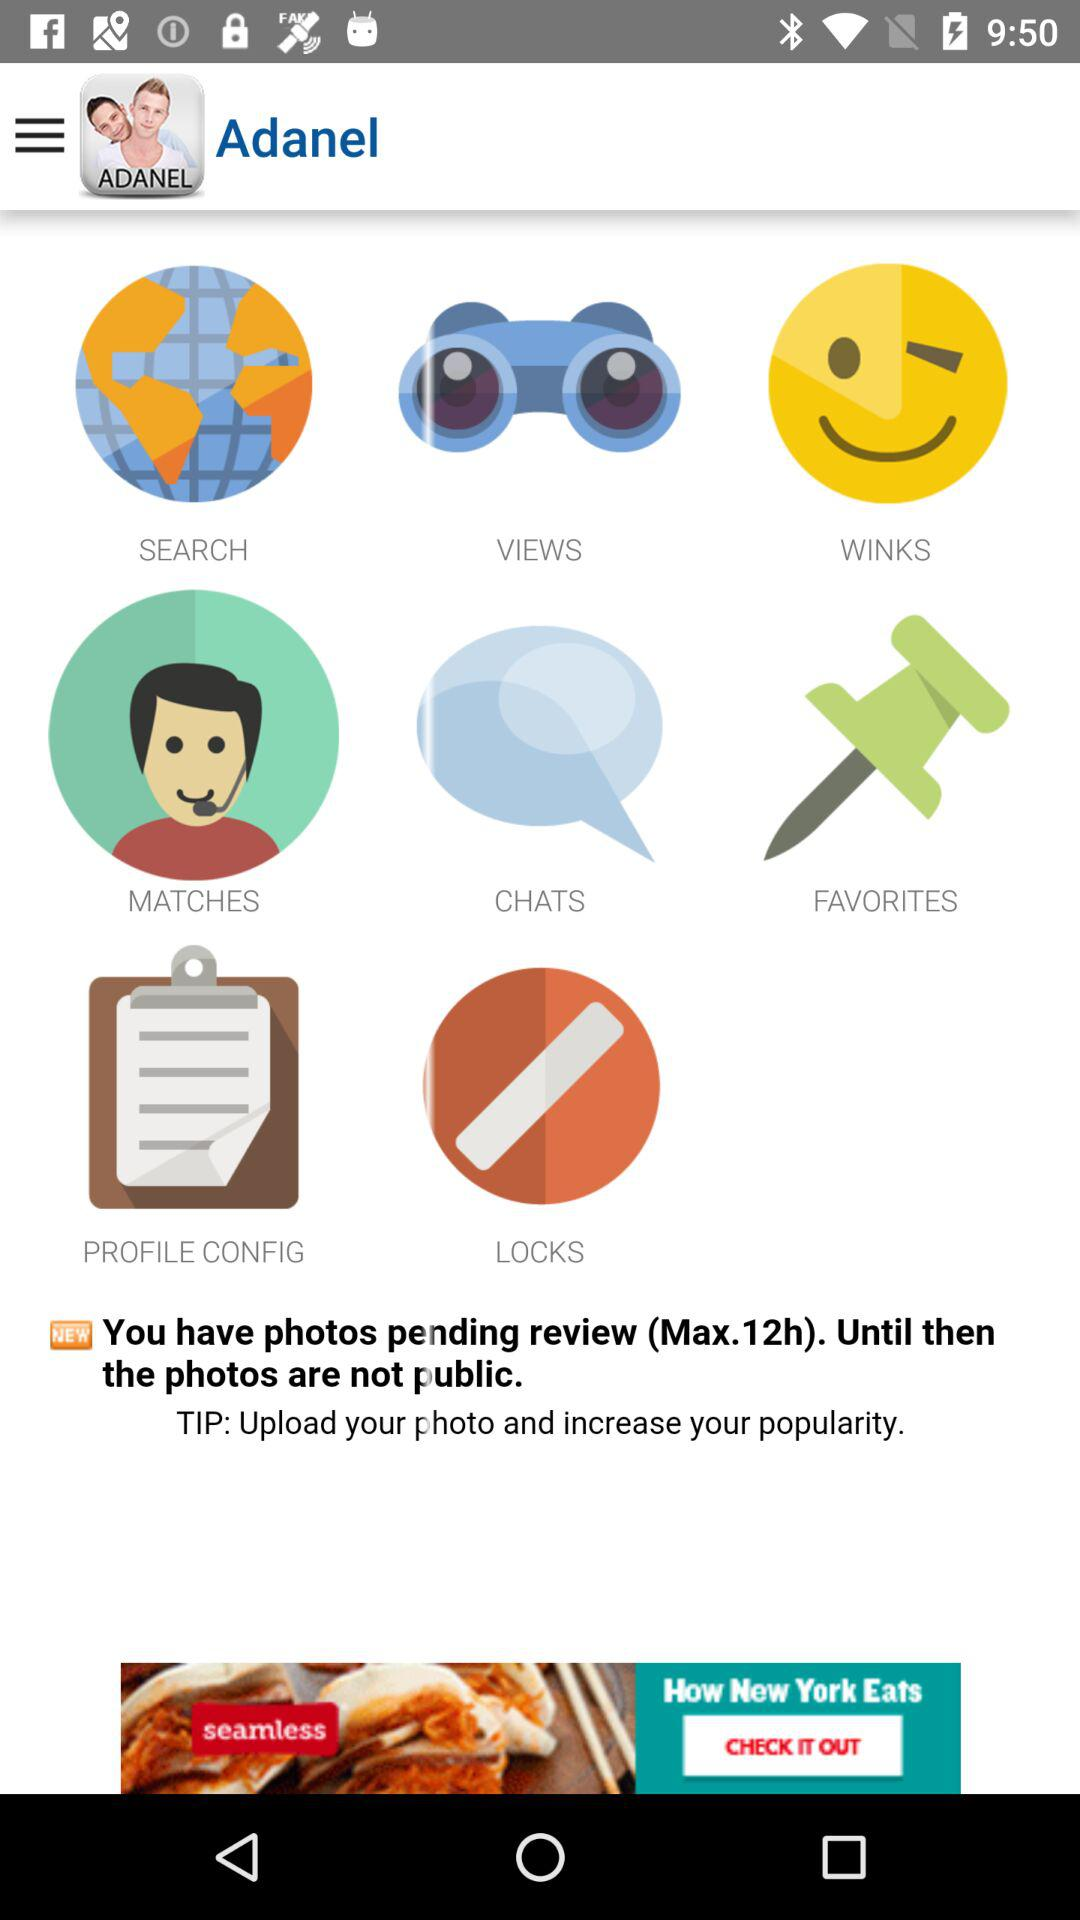What are the available options? The available options are "SEARCH", "VIEWS", "WINKS", "MATCHES", "CHATS", "FAVORITES", "PROFILE CONFIG" and "LOCKS". 